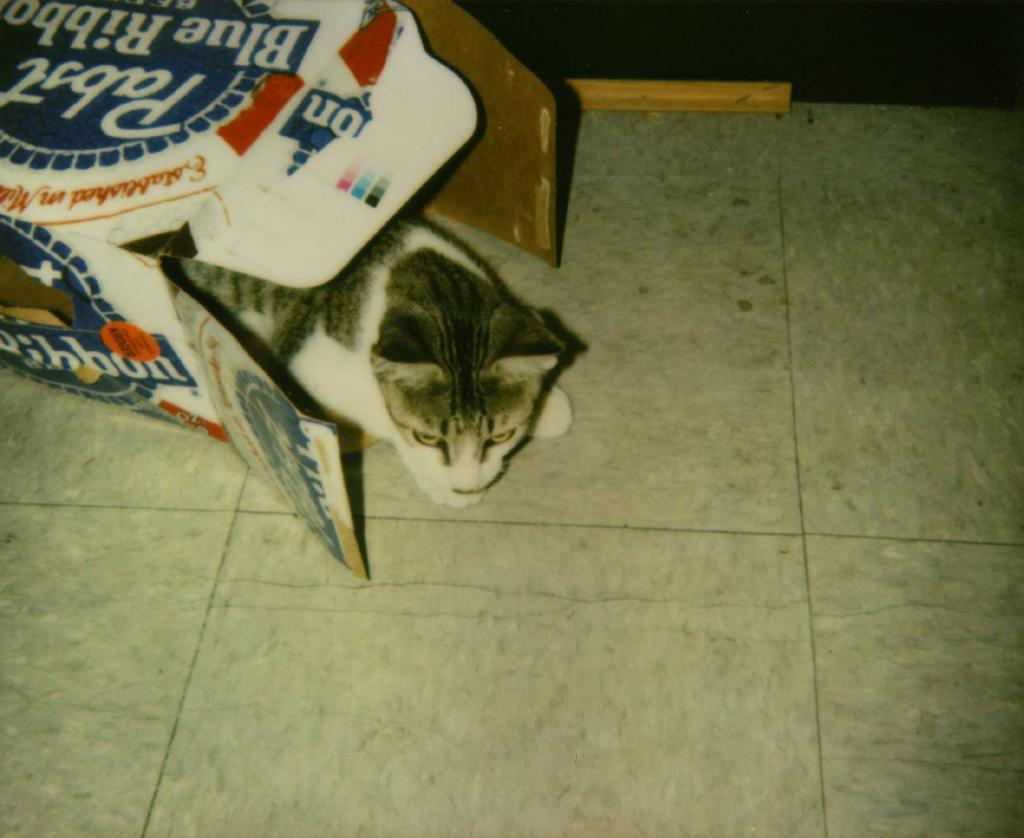What animal is present in the image? There is a cat in the image. Where is the cat located? The cat is in a cardboard box. What colors can be seen on the cat? The cat has white and gray colors. What colors are present on the cardboard box? The cardboard box has white and blue colors. What color is the floor in the image? The floor in the image is cream-colored. What type of apparel is the cat wearing in the image? The cat is not wearing any apparel in the image. How does the lock on the cardboard box work in the image? There is no lock present on the cardboard box in the image. 